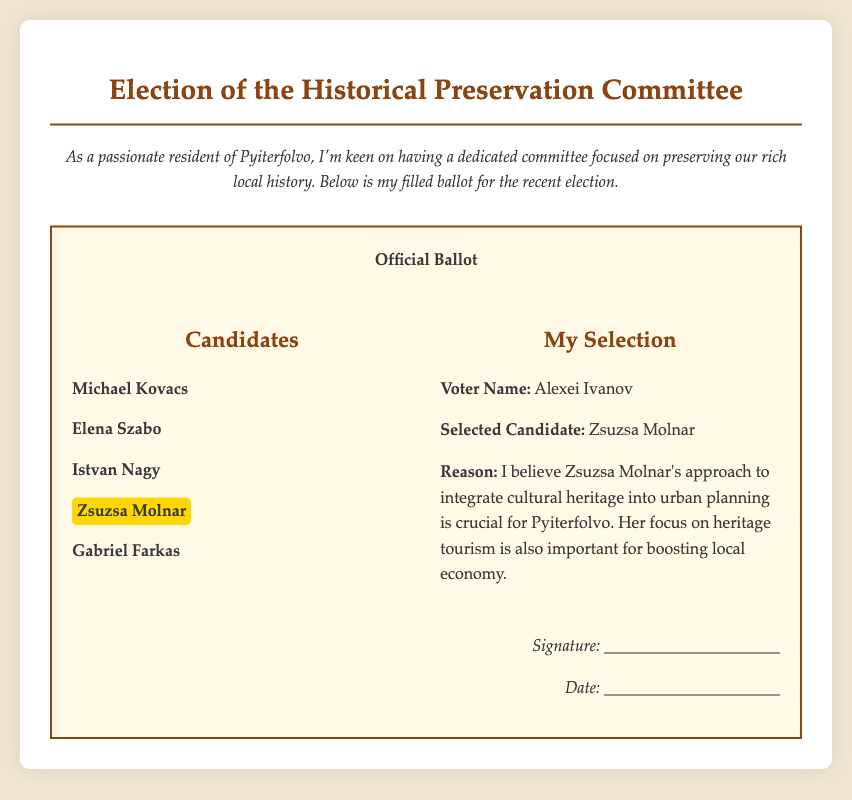What is the title of the document? The title is the main heading at the top of the document, which states the purpose of the ballot.
Answer: Election of the Historical Preservation Committee Who is the selected candidate by Alexei Ivanov? This information is found in the section detailing the voter's selection, which identifies the chosen candidate.
Answer: Zsuzsa Molnar What is Zsuzsa Molnar's main focus in her platform? The platform details specific interests and policies that candidates advocate, here it mentions her focus areas.
Answer: Integrate cultural heritage into urban planning How many candidates are listed on the ballot? The total number of candidates is counted in the candidates section of the ballot.
Answer: Five What is the reason Alexei Ivanov chose Zsuzsa Molnar? The reason is included right after the selected candidate's name, explaining the rationale behind the vote.
Answer: Important for boosting local economy What is the date field labeled for? The label indicates a section meant for the date of the vote or signature, typically required for formal documentation.
Answer: Signature date Who authored the ballot? The voter's name is included in the ballot along with their selection, identifying the individual responsible for this vote.
Answer: Alexei Ivanov What kind of committee is being elected? It refers to the specific group being voted for, highlighted in the title of the document.
Answer: Historical Preservation Committee What colors are used in the document’s design? The design includes distinctive color choices noticeable in the text and background, reflecting its style.
Answer: Brown, white, and light beige 